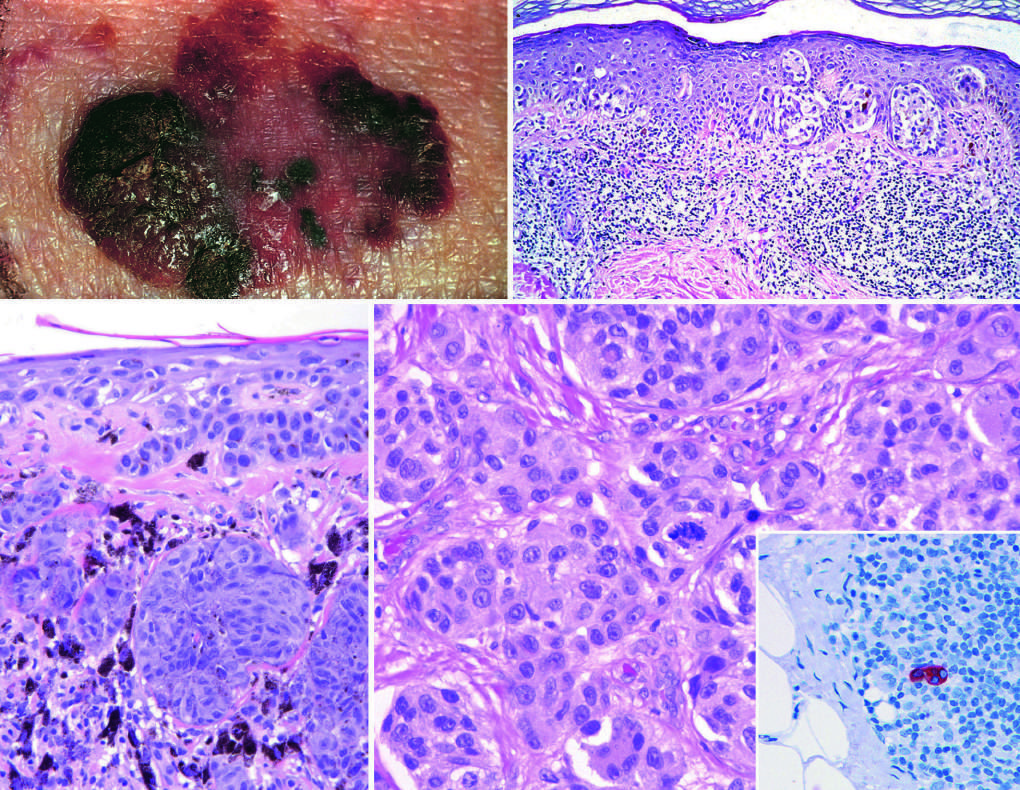what indicates superficial growth?
Answer the question using a single word or phrase. Macular areas 